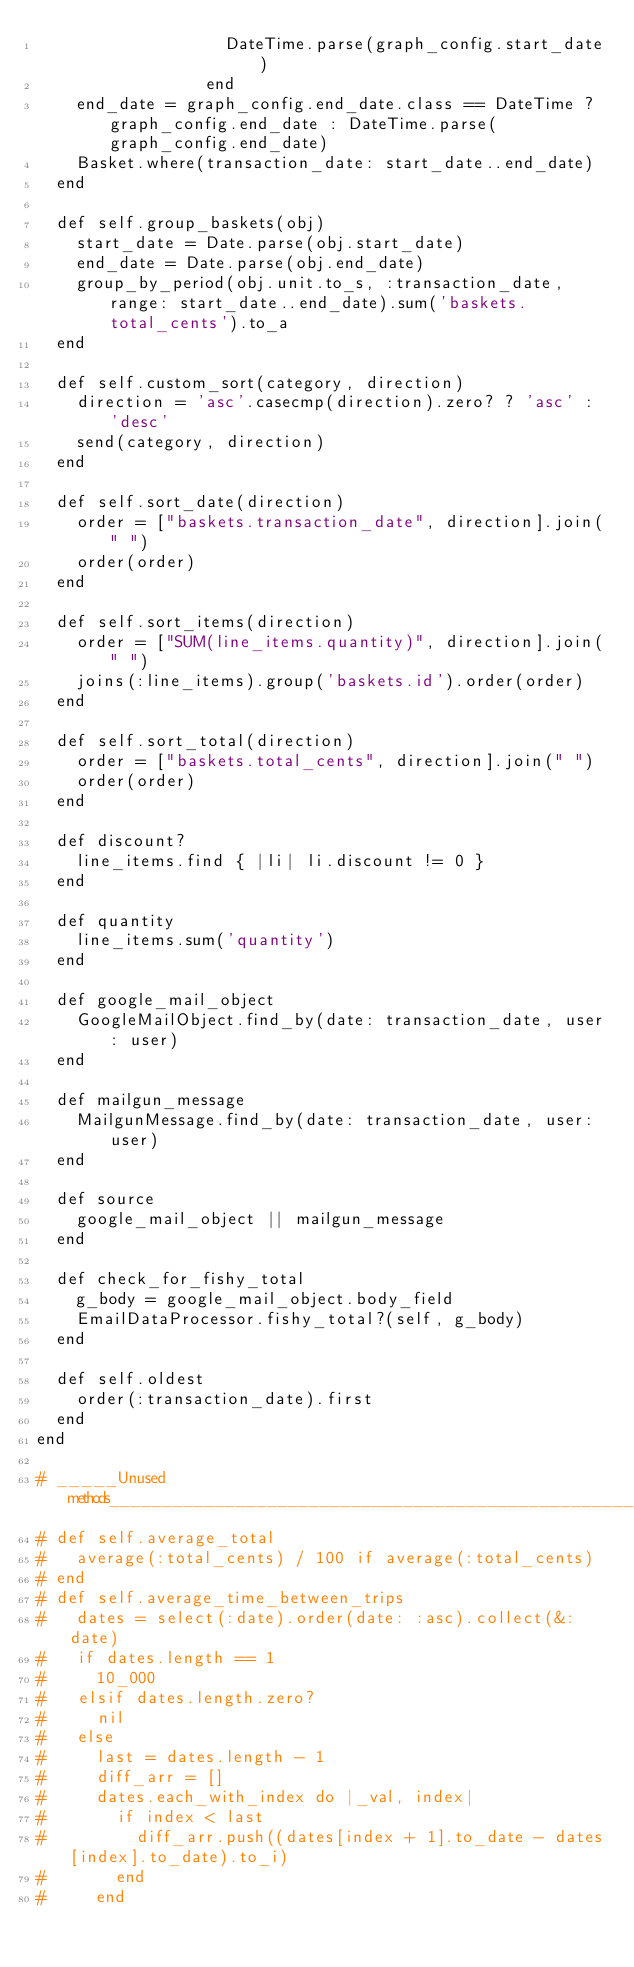Convert code to text. <code><loc_0><loc_0><loc_500><loc_500><_Ruby_>                   DateTime.parse(graph_config.start_date)
                 end
    end_date = graph_config.end_date.class == DateTime ? graph_config.end_date : DateTime.parse(graph_config.end_date)
    Basket.where(transaction_date: start_date..end_date)
  end

  def self.group_baskets(obj)
    start_date = Date.parse(obj.start_date)
    end_date = Date.parse(obj.end_date)
    group_by_period(obj.unit.to_s, :transaction_date, range: start_date..end_date).sum('baskets.total_cents').to_a
  end

  def self.custom_sort(category, direction)
    direction = 'asc'.casecmp(direction).zero? ? 'asc' : 'desc'
    send(category, direction)
  end

  def self.sort_date(direction)
    order = ["baskets.transaction_date", direction].join(" ")
    order(order)
  end

  def self.sort_items(direction)
    order = ["SUM(line_items.quantity)", direction].join(" ")
    joins(:line_items).group('baskets.id').order(order)
  end

  def self.sort_total(direction)
    order = ["baskets.total_cents", direction].join(" ")
    order(order)
  end

  def discount?
    line_items.find { |li| li.discount != 0 }
  end

  def quantity
    line_items.sum('quantity')
  end

  def google_mail_object
    GoogleMailObject.find_by(date: transaction_date, user: user)
  end

  def mailgun_message
    MailgunMessage.find_by(date: transaction_date, user: user)
  end

  def source
    google_mail_object || mailgun_message
  end

  def check_for_fishy_total
    g_body = google_mail_object.body_field
    EmailDataProcessor.fishy_total?(self, g_body)
  end

  def self.oldest
    order(:transaction_date).first
  end
end

# _____Unused methods____________________________________________________________
# def self.average_total
#   average(:total_cents) / 100 if average(:total_cents)
# end
# def self.average_time_between_trips
#   dates = select(:date).order(date: :asc).collect(&:date)
#   if dates.length == 1
#     10_000
#   elsif dates.length.zero?
#     nil
#   else
#     last = dates.length - 1
#     diff_arr = []
#     dates.each_with_index do |_val, index|
#       if index < last
#         diff_arr.push((dates[index + 1].to_date - dates[index].to_date).to_i)
#       end
#     end</code> 